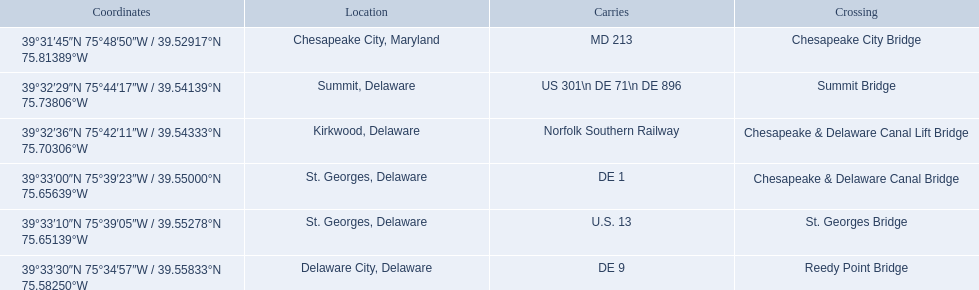Which are the bridges? Chesapeake City Bridge, Summit Bridge, Chesapeake & Delaware Canal Lift Bridge, Chesapeake & Delaware Canal Bridge, St. Georges Bridge, Reedy Point Bridge. Which are in delaware? Summit Bridge, Chesapeake & Delaware Canal Lift Bridge, Chesapeake & Delaware Canal Bridge, St. Georges Bridge, Reedy Point Bridge. Give me the full table as a dictionary. {'header': ['Coordinates', 'Location', 'Carries', 'Crossing'], 'rows': [['39°31′45″N 75°48′50″W\ufeff / \ufeff39.52917°N 75.81389°W', 'Chesapeake City, Maryland', 'MD 213', 'Chesapeake City Bridge'], ['39°32′29″N 75°44′17″W\ufeff / \ufeff39.54139°N 75.73806°W', 'Summit, Delaware', 'US 301\\n DE 71\\n DE 896', 'Summit Bridge'], ['39°32′36″N 75°42′11″W\ufeff / \ufeff39.54333°N 75.70306°W', 'Kirkwood, Delaware', 'Norfolk Southern Railway', 'Chesapeake & Delaware Canal Lift Bridge'], ['39°33′00″N 75°39′23″W\ufeff / \ufeff39.55000°N 75.65639°W', 'St.\xa0Georges, Delaware', 'DE 1', 'Chesapeake & Delaware Canal Bridge'], ['39°33′10″N 75°39′05″W\ufeff / \ufeff39.55278°N 75.65139°W', 'St.\xa0Georges, Delaware', 'U.S.\xa013', 'St.\xa0Georges Bridge'], ['39°33′30″N 75°34′57″W\ufeff / \ufeff39.55833°N 75.58250°W', 'Delaware City, Delaware', 'DE\xa09', 'Reedy Point Bridge']]} Of these, which carries de 9? Reedy Point Bridge. 